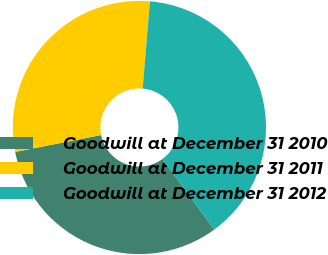<chart> <loc_0><loc_0><loc_500><loc_500><pie_chart><fcel>Goodwill at December 31 2010<fcel>Goodwill at December 31 2011<fcel>Goodwill at December 31 2012<nl><fcel>31.98%<fcel>29.42%<fcel>38.6%<nl></chart> 